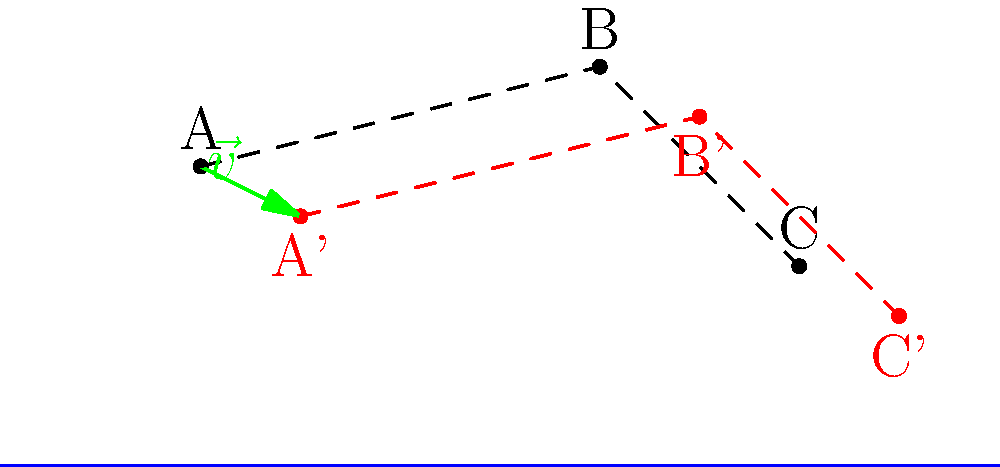The Coast Guard is considering optimizing a navigation channel by translating the positions of three buoys. The original positions of the buoys are A(20,30), B(60,40), and C(80,20). If all buoys are translated by the vector $\vec{v} = (10, -5)$, what are the new coordinates of buoy B? To find the new coordinates of buoy B after translation, we need to follow these steps:

1) The original coordinates of buoy B are (60, 40).

2) The translation vector $\vec{v}$ is (10, -5).

3) To translate a point, we add the components of the translation vector to the coordinates of the point:
   
   New x-coordinate = Original x-coordinate + x-component of $\vec{v}$
   New y-coordinate = Original y-coordinate + y-component of $\vec{v}$

4) For buoy B:
   New x-coordinate = 60 + 10 = 70
   New y-coordinate = 40 + (-5) = 35

5) Therefore, the new coordinates of buoy B are (70, 35).

This translation moves all buoys 10 units to the right and 5 units down, optimizing the navigation channel while maintaining the relative positions of the buoys.
Answer: (70, 35) 